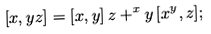Convert formula to latex. <formula><loc_0><loc_0><loc_500><loc_500>[ x , y z ] & = [ x , y ] \, z + ^ { x } y \, [ x ^ { y } , z ] ;</formula> 